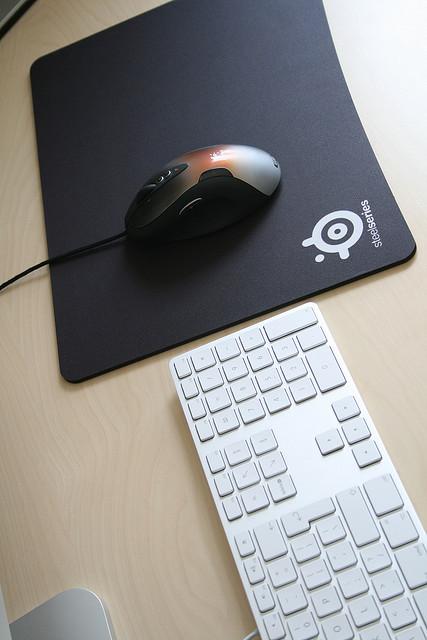Is the keyboard the same color as the majority of computer keyboards in the world?
Give a very brief answer. Yes. Does this mouse have a cord?
Be succinct. Yes. What brand of mouse is that?
Answer briefly. Hp. Is this a wireless mouse?
Concise answer only. No. Does the surface of the mousepad appear to be large enough for the mouse to be moved freely upon?
Write a very short answer. Yes. How many mouse pads ar? there?
Concise answer only. 1. 